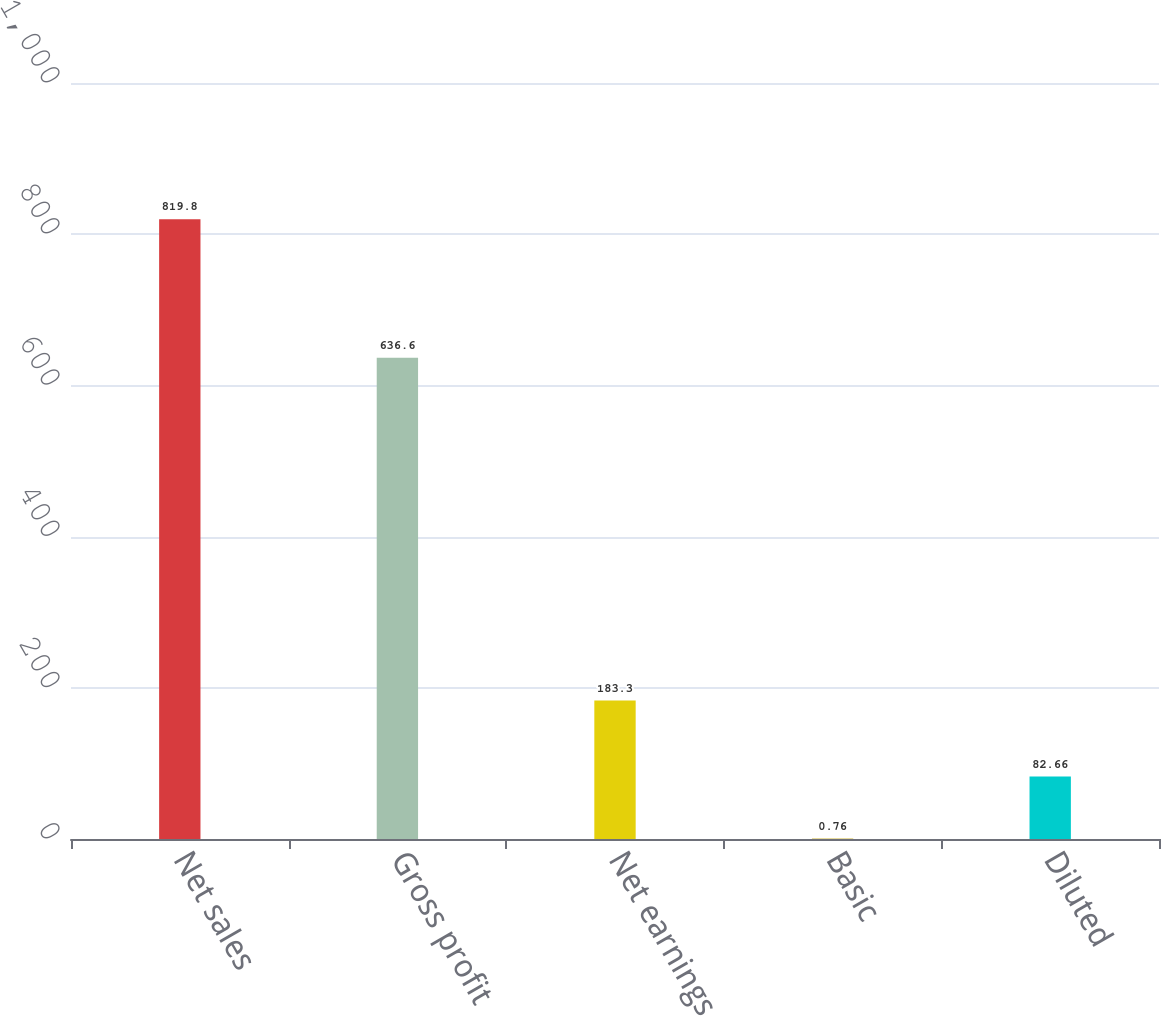Convert chart. <chart><loc_0><loc_0><loc_500><loc_500><bar_chart><fcel>Net sales<fcel>Gross profit<fcel>Net earnings<fcel>Basic<fcel>Diluted<nl><fcel>819.8<fcel>636.6<fcel>183.3<fcel>0.76<fcel>82.66<nl></chart> 